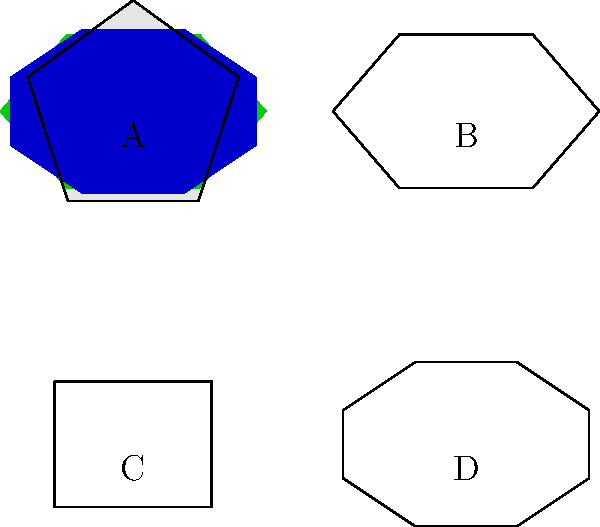Which of these gemstones is associated with the character Galadriel in J.R.R. Tolkien's "The Lord of the Rings" trilogy? To answer this question, let's examine each gemstone and its literary connection:

1. Gemstone A: This is a diamond, known for its clear or white color. While diamonds appear in various works of literature, they are not specifically associated with Galadriel in Tolkien's works.

2. Gemstone B: This green gemstone is an emerald. Emeralds are not particularly associated with Galadriel in "The Lord of the Rings."

3. Gemstone C: This red gemstone is a ruby. Rubies are mentioned in Tolkien's works but are not specifically linked to Galadriel.

4. Gemstone D: This blue gemstone is a sapphire. In "The Lord of the Rings," Galadriel is described as wearing a ring called Nenya, also known as the Ring of Water or the Ring of Adamant. This ring is said to be made of mithril and set with a white stone, but it has a strong association with the color blue and water.

While the ring itself is not explicitly described as a sapphire, the blue color of this gemstone and its association with water align most closely with Galadriel's ring Nenya and her overall character portrayal in the trilogy.

Therefore, the gemstone most associated with Galadriel in "The Lord of the Rings" is the sapphire, represented by Gemstone D.
Answer: D 